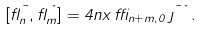Convert formula to latex. <formula><loc_0><loc_0><loc_500><loc_500>[ \gamma _ { n } ^ { \mu } , \gamma _ { m } ^ { \nu } ] = 4 n x \, \delta _ { n + m , 0 } \, \eta ^ { \mu \nu } .</formula> 